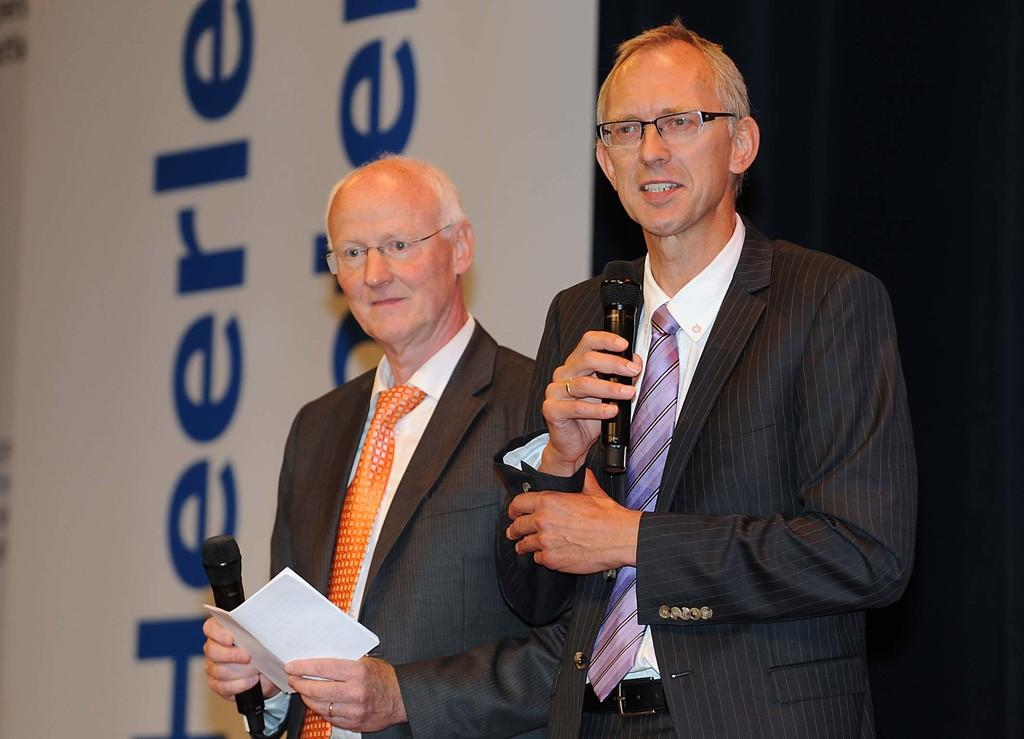How many people are in the image? There are two persons in the image. What are the persons holding in their hands? Both persons are holding microphones. Is there any additional object being held by one of the persons? Yes, one of the persons is holding a paper. What can be seen in the background of the image? There is a banner in the background of the image. Can you tell me how many bottles of soda are on the table in the image? There is no table or soda bottles present in the image. What type of servant is standing next to the persons in the image? There is no servant present in the image. 